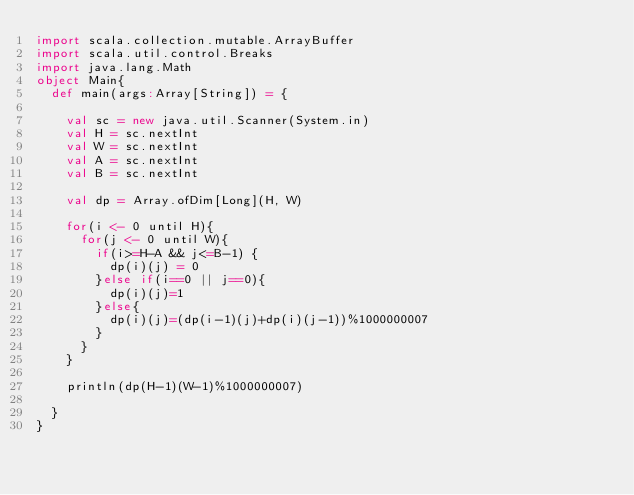Convert code to text. <code><loc_0><loc_0><loc_500><loc_500><_Scala_>import scala.collection.mutable.ArrayBuffer
import scala.util.control.Breaks
import java.lang.Math
object Main{
  def main(args:Array[String]) = {

    val sc = new java.util.Scanner(System.in)
    val H = sc.nextInt
    val W = sc.nextInt
    val A = sc.nextInt
    val B = sc.nextInt

    val dp = Array.ofDim[Long](H, W)

    for(i <- 0 until H){
      for(j <- 0 until W){
        if(i>=H-A && j<=B-1) {
          dp(i)(j) = 0
        }else if(i==0 || j==0){
          dp(i)(j)=1
        }else{
          dp(i)(j)=(dp(i-1)(j)+dp(i)(j-1))%1000000007
        }
      }
    }

    println(dp(H-1)(W-1)%1000000007)

  }
}
</code> 